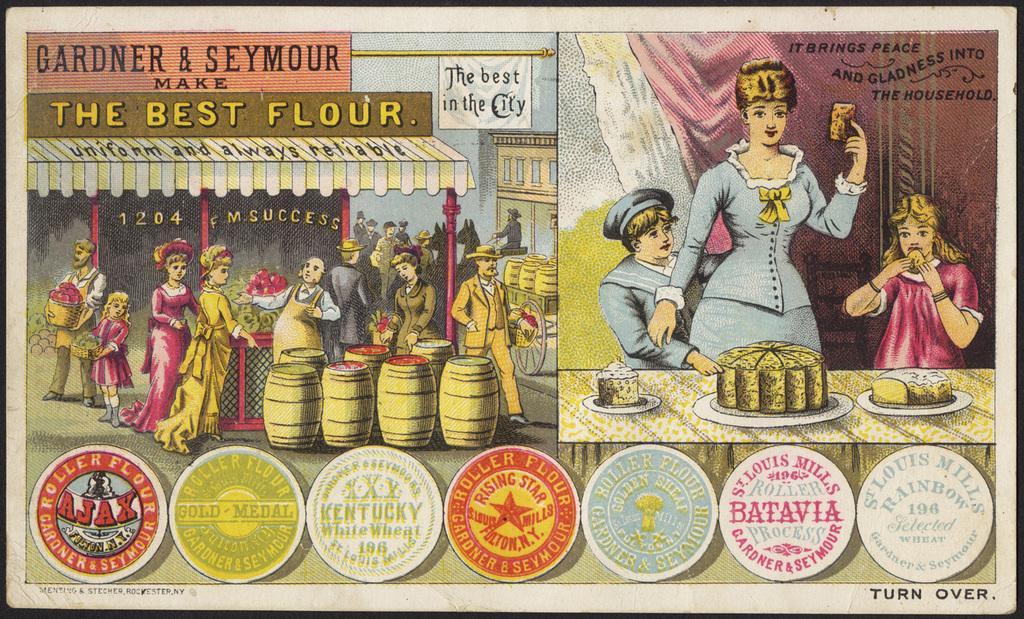Please provide a concise description of this image. In this poster there is a woman on the right side with kids on either side of her in front of a table with cake and food on it, on the left side there is a man standing,he wore apron and many people are walking on either side of the road, in front of him there are barrels and below there are stamps. 